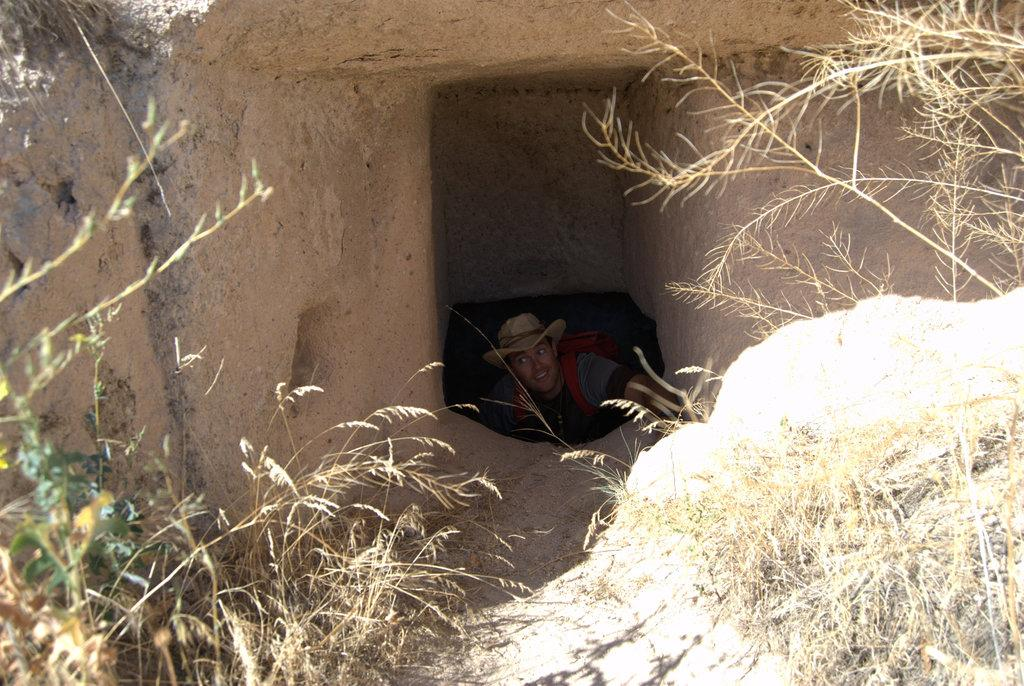What is the main feature of the image? There is a cave in the image. Who or what is inside the cave? There is a man inside the cave. What is the man wearing on his head? The man is wearing a hat. What is the man carrying on his body? The man is wearing a bag. What type of vegetation can be seen at the bottom of the image? There are plants at the bottom of the image. What is the man standing in front of in the image? There is a wall in the image. What type of whip is the man using to force the plants to grow in the image? There is no whip present in the image, and the man is not forcing the plants to grow. 